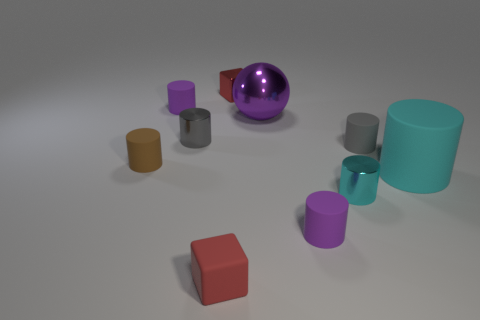Subtract 4 cylinders. How many cylinders are left? 3 Subtract all large cyan rubber cylinders. How many cylinders are left? 6 Subtract all purple cylinders. How many cylinders are left? 5 Subtract all red cylinders. Subtract all cyan spheres. How many cylinders are left? 7 Subtract all balls. How many objects are left? 9 Subtract all cyan matte things. Subtract all red matte blocks. How many objects are left? 8 Add 3 tiny gray matte cylinders. How many tiny gray matte cylinders are left? 4 Add 3 tiny brown things. How many tiny brown things exist? 4 Subtract 0 cyan spheres. How many objects are left? 10 